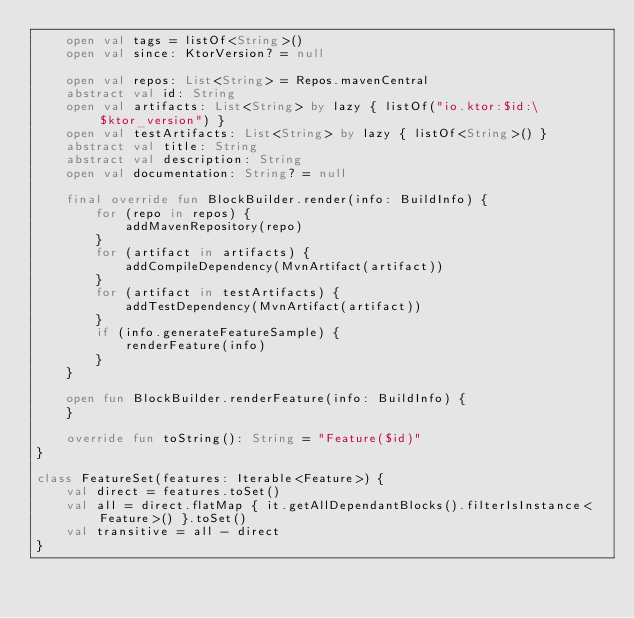Convert code to text. <code><loc_0><loc_0><loc_500><loc_500><_Kotlin_>    open val tags = listOf<String>()
    open val since: KtorVersion? = null

    open val repos: List<String> = Repos.mavenCentral
    abstract val id: String
    open val artifacts: List<String> by lazy { listOf("io.ktor:$id:\$ktor_version") }
    open val testArtifacts: List<String> by lazy { listOf<String>() }
    abstract val title: String
    abstract val description: String
    open val documentation: String? = null

    final override fun BlockBuilder.render(info: BuildInfo) {
        for (repo in repos) {
            addMavenRepository(repo)
        }
        for (artifact in artifacts) {
            addCompileDependency(MvnArtifact(artifact))
        }
        for (artifact in testArtifacts) {
            addTestDependency(MvnArtifact(artifact))
        }
        if (info.generateFeatureSample) {
            renderFeature(info)
        }
    }

    open fun BlockBuilder.renderFeature(info: BuildInfo) {
    }

    override fun toString(): String = "Feature($id)"
}

class FeatureSet(features: Iterable<Feature>) {
    val direct = features.toSet()
    val all = direct.flatMap { it.getAllDependantBlocks().filterIsInstance<Feature>() }.toSet()
    val transitive = all - direct
}
</code> 